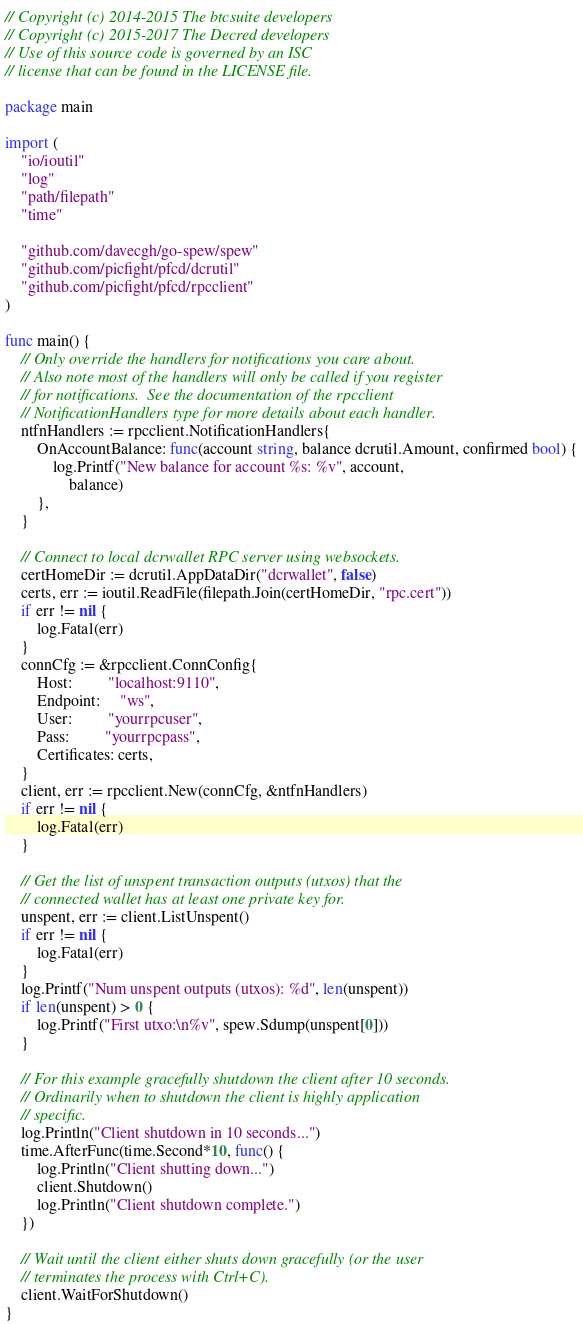Convert code to text. <code><loc_0><loc_0><loc_500><loc_500><_Go_>// Copyright (c) 2014-2015 The btcsuite developers
// Copyright (c) 2015-2017 The Decred developers
// Use of this source code is governed by an ISC
// license that can be found in the LICENSE file.

package main

import (
	"io/ioutil"
	"log"
	"path/filepath"
	"time"

	"github.com/davecgh/go-spew/spew"
	"github.com/picfight/pfcd/dcrutil"
	"github.com/picfight/pfcd/rpcclient"
)

func main() {
	// Only override the handlers for notifications you care about.
	// Also note most of the handlers will only be called if you register
	// for notifications.  See the documentation of the rpcclient
	// NotificationHandlers type for more details about each handler.
	ntfnHandlers := rpcclient.NotificationHandlers{
		OnAccountBalance: func(account string, balance dcrutil.Amount, confirmed bool) {
			log.Printf("New balance for account %s: %v", account,
				balance)
		},
	}

	// Connect to local dcrwallet RPC server using websockets.
	certHomeDir := dcrutil.AppDataDir("dcrwallet", false)
	certs, err := ioutil.ReadFile(filepath.Join(certHomeDir, "rpc.cert"))
	if err != nil {
		log.Fatal(err)
	}
	connCfg := &rpcclient.ConnConfig{
		Host:         "localhost:9110",
		Endpoint:     "ws",
		User:         "yourrpcuser",
		Pass:         "yourrpcpass",
		Certificates: certs,
	}
	client, err := rpcclient.New(connCfg, &ntfnHandlers)
	if err != nil {
		log.Fatal(err)
	}

	// Get the list of unspent transaction outputs (utxos) that the
	// connected wallet has at least one private key for.
	unspent, err := client.ListUnspent()
	if err != nil {
		log.Fatal(err)
	}
	log.Printf("Num unspent outputs (utxos): %d", len(unspent))
	if len(unspent) > 0 {
		log.Printf("First utxo:\n%v", spew.Sdump(unspent[0]))
	}

	// For this example gracefully shutdown the client after 10 seconds.
	// Ordinarily when to shutdown the client is highly application
	// specific.
	log.Println("Client shutdown in 10 seconds...")
	time.AfterFunc(time.Second*10, func() {
		log.Println("Client shutting down...")
		client.Shutdown()
		log.Println("Client shutdown complete.")
	})

	// Wait until the client either shuts down gracefully (or the user
	// terminates the process with Ctrl+C).
	client.WaitForShutdown()
}
</code> 